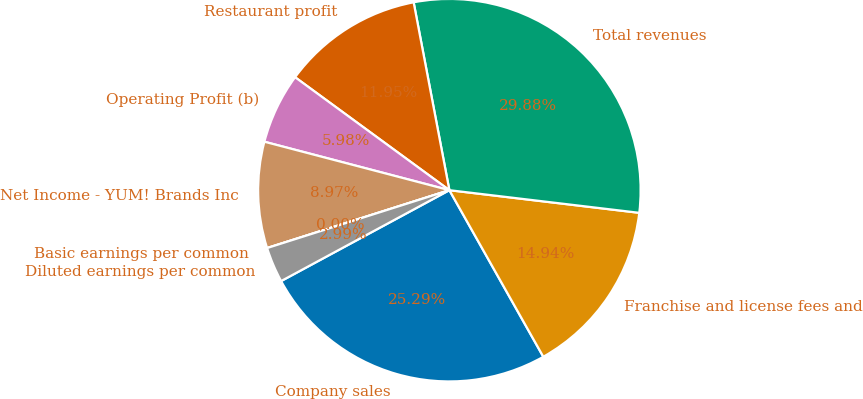Convert chart. <chart><loc_0><loc_0><loc_500><loc_500><pie_chart><fcel>Company sales<fcel>Franchise and license fees and<fcel>Total revenues<fcel>Restaurant profit<fcel>Operating Profit (b)<fcel>Net Income - YUM! Brands Inc<fcel>Basic earnings per common<fcel>Diluted earnings per common<nl><fcel>25.29%<fcel>14.94%<fcel>29.88%<fcel>11.95%<fcel>5.98%<fcel>8.97%<fcel>0.0%<fcel>2.99%<nl></chart> 